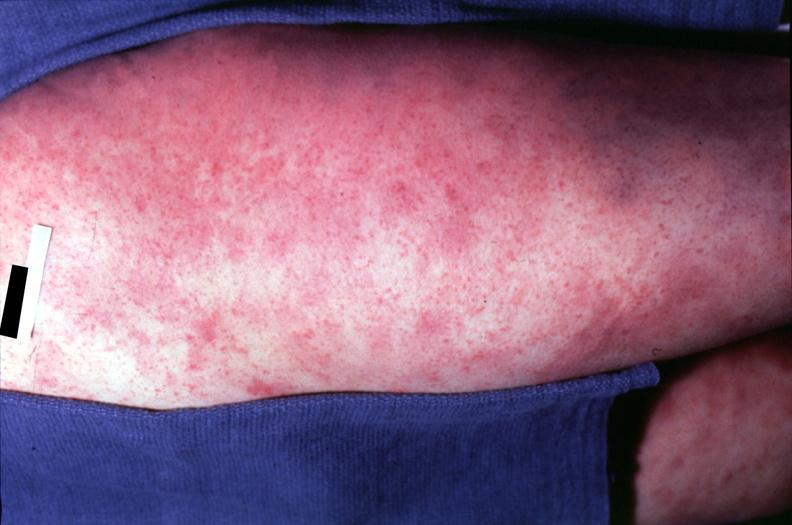what does this image show?
Answer the question using a single word or phrase. Skin 